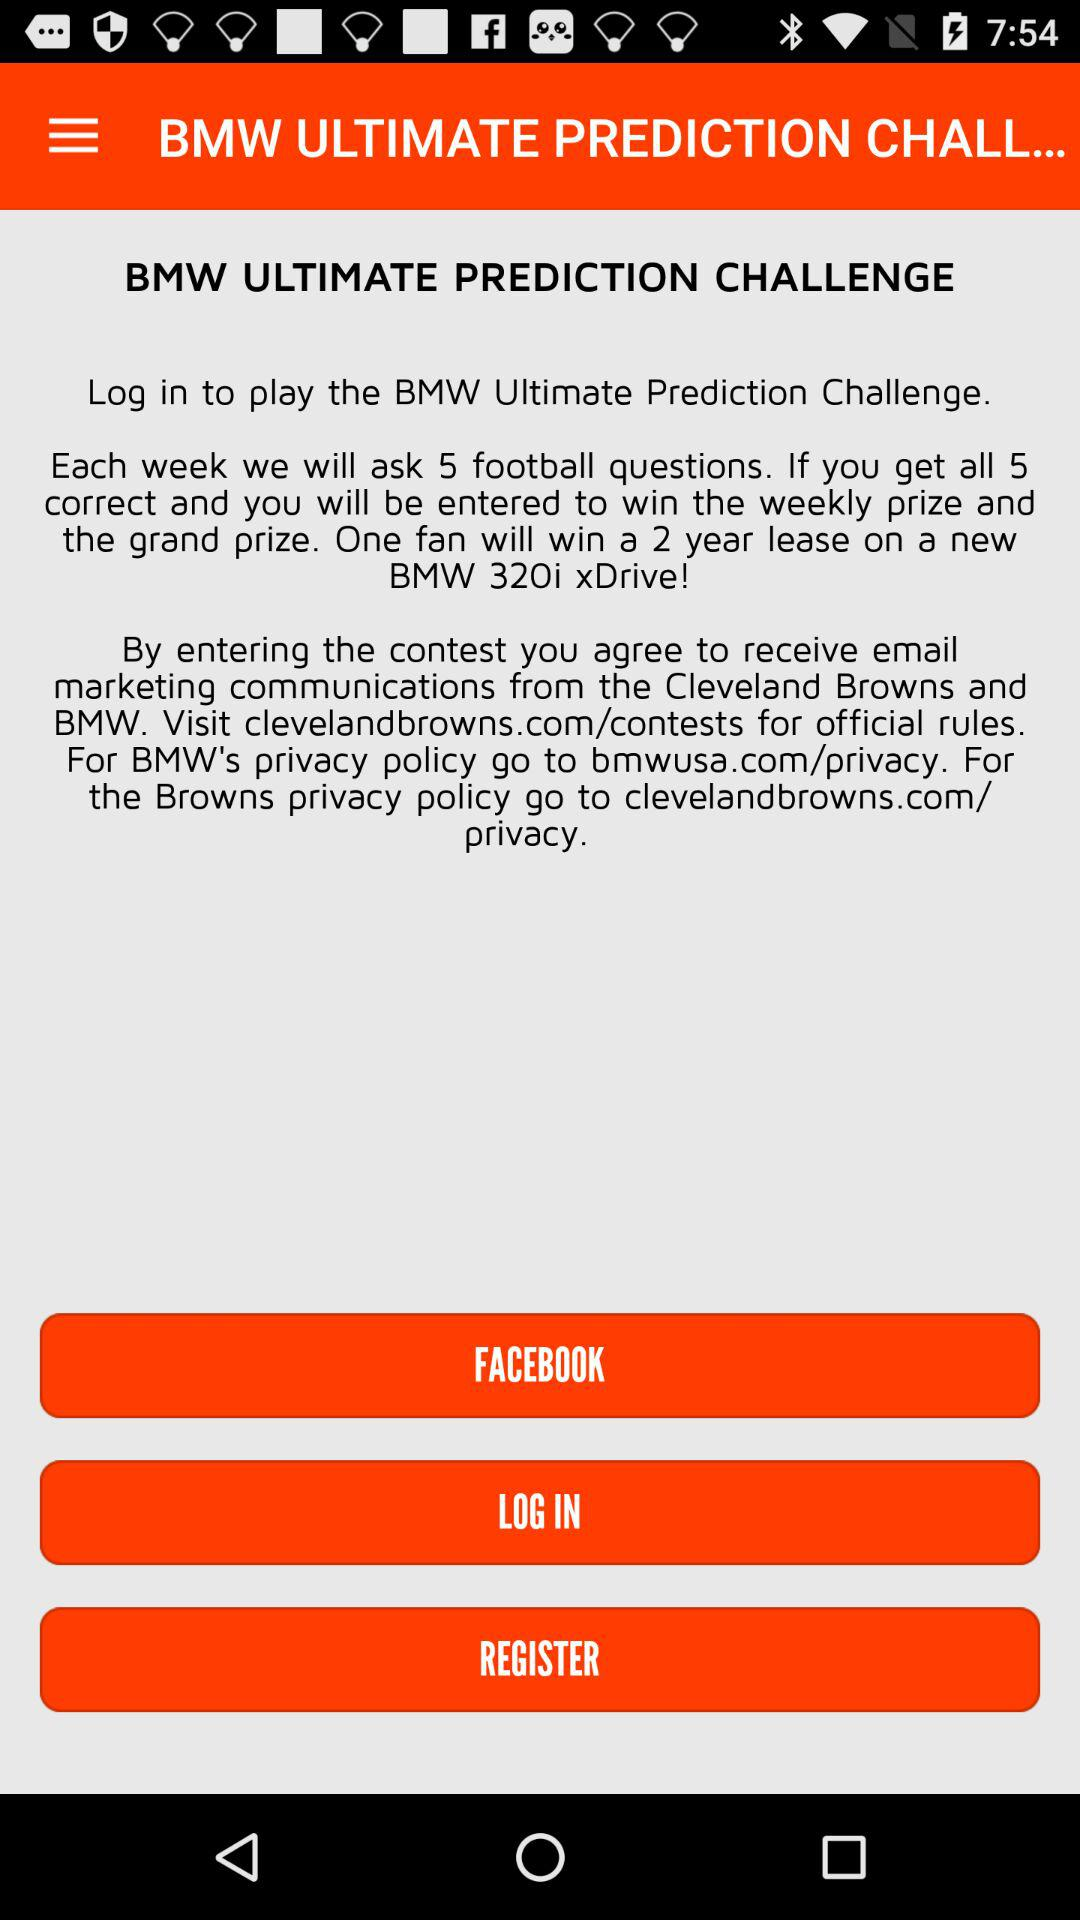Which application is used to login?
When the provided information is insufficient, respond with <no answer>. <no answer> 